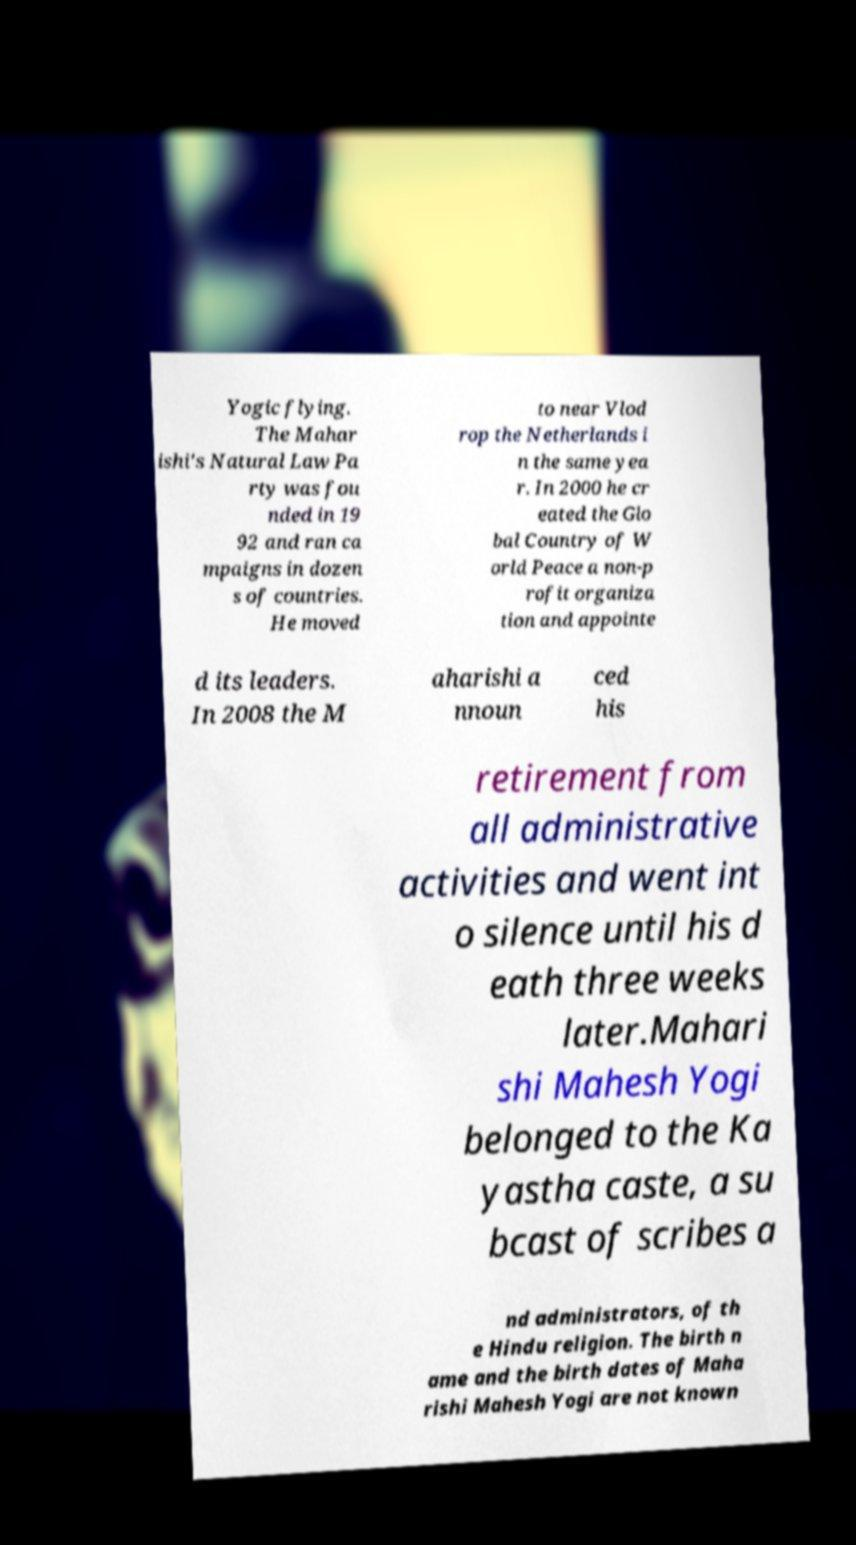What messages or text are displayed in this image? I need them in a readable, typed format. Yogic flying. The Mahar ishi's Natural Law Pa rty was fou nded in 19 92 and ran ca mpaigns in dozen s of countries. He moved to near Vlod rop the Netherlands i n the same yea r. In 2000 he cr eated the Glo bal Country of W orld Peace a non-p rofit organiza tion and appointe d its leaders. In 2008 the M aharishi a nnoun ced his retirement from all administrative activities and went int o silence until his d eath three weeks later.Mahari shi Mahesh Yogi belonged to the Ka yastha caste, a su bcast of scribes a nd administrators, of th e Hindu religion. The birth n ame and the birth dates of Maha rishi Mahesh Yogi are not known 